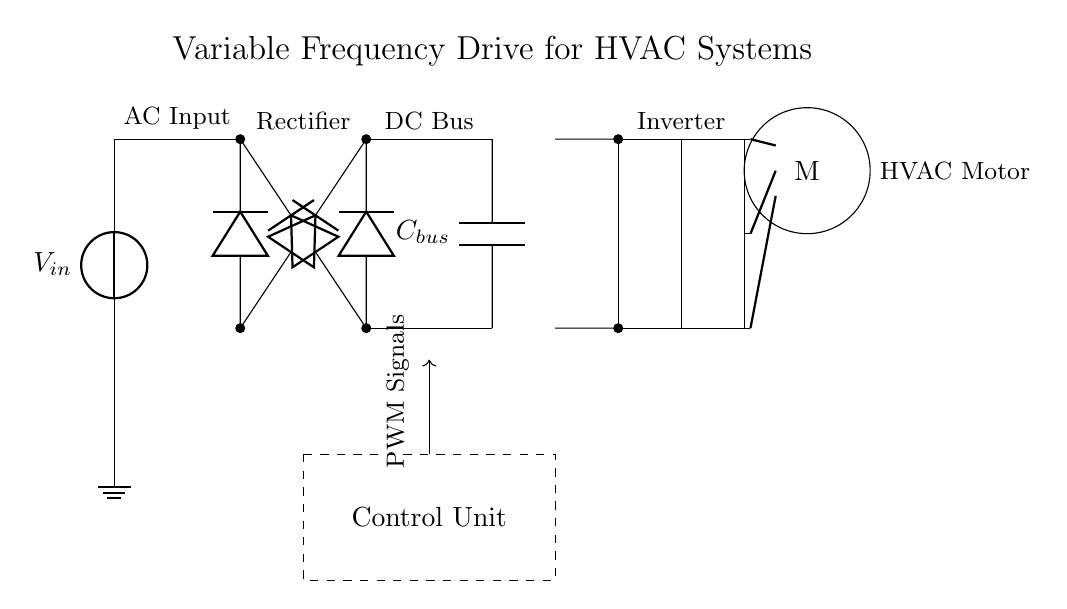What is the input voltage of the circuit? The input voltage is indicated in the circuit as V_in, which is the voltage connected to the power source at the top left corner.
Answer: V_in What component converts AC to DC in the circuit? The component that converts alternating current to direct current is the rectifier, which consists of multiple diodes and is illustrated at the top right area of the circuit diagram.
Answer: Rectifier What is the function of the control unit in this circuit? The control unit is responsible for generating pulse-width modulation (PWM) signals to control the operation of the inverter and, subsequently, the motor speed and behavior. This is indicated by the dashed rectangle labeled Control Unit and the arrow pointing to the PWM Signals.
Answer: PWM Signals How many diodes are used in the rectifier? The rectifier contains four diodes for converting AC to DC, as represented in pairs in the circuit diagram.
Answer: Four What type of motor is represented in the circuit? The motor shown in the circuit diagram is a standard electrical motor used in HVAC systems, which is indicated by the symbol M inside a circle.
Answer: HVAC Motor What is the purpose of the capacitor in the DC bus? The capacitor, labeled as C_bus, smooths the DC voltage output from the rectifier, helping to stabilize the voltage supplied to the inverter. This function is essential for maintaining consistent power supply to the motor.
Answer: Stabilize voltage Which components are part of the inverter section of the circuit? The inverter section consists of four N-channel MOSFETs, depicted in a series arrangement just below the DC bus, which convert the DC voltage back into AC for driving the motor.
Answer: N-channel MOSFETs 